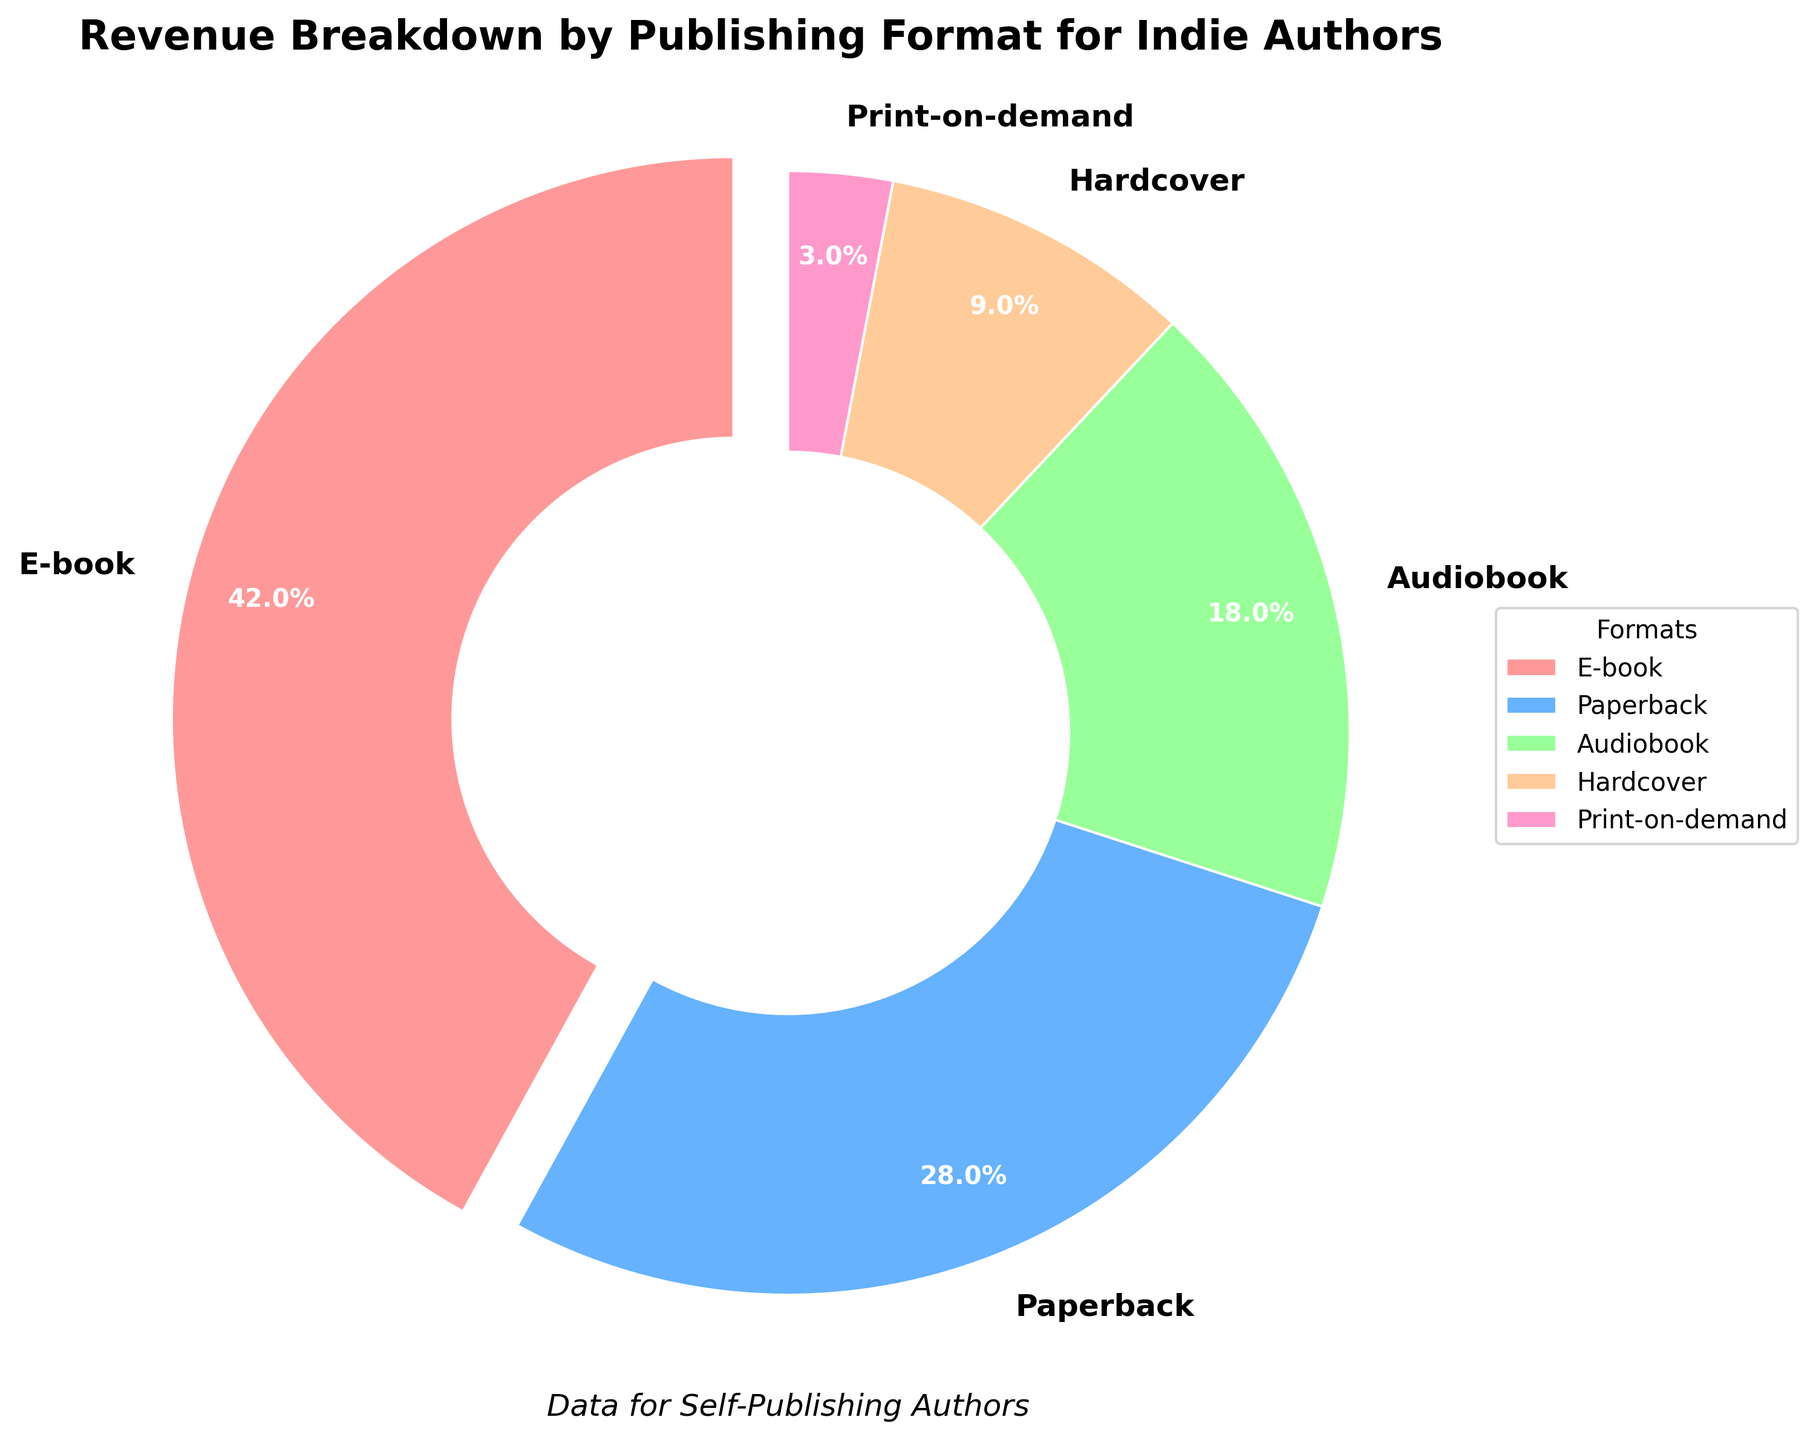What percentage of the revenue comes from e-books? The pie chart shows that the segment representing e-books is labeled with the percentage value.
Answer: 42% Which publishing format contributes the least to the revenue? By observing the size of the slices, the smallest slice will indicate the format contributing the least to the revenue.
Answer: Print-on-demand What is the combined percentage of revenue from paperback and hardcover formats? The percentages for paperback and hardcover are 28% and 9%, respectively. Summing them up, we get 28 + 9 = 37%.
Answer: 37% How does the revenue from audiobooks compare to that from print-on-demand? The percentages for audiobooks and print-on-demand are 18% and 3%, respectively. Audiobook revenue is greater than print-on-demand revenue.
Answer: Audiobooks > Print-on-demand Which color represents the hardcover format on the pie chart? The legend indicates the color associated with each format. The color for hardcover needs to be identified from this legend.
Answer: Peach (or '#FFCC99') What is the difference in revenue percentages between e-books and paperbacks? E-books contribute 42% while paperbacks contribute 28%. The difference is calculated as 42 - 28 = 14%.
Answer: 14% How much more revenue does the e-book format generate compared to the audiobook format? The revenue percentages for e-books and audiobooks are 42% and 18%, respectively. The difference is 42 - 18 = 24%.
Answer: 24% What formats are represented by the two largest segments on the pie chart? The largest percentages will correspond to the largest segments, hence identifying the top two formats.
Answer: E-book and Paperback What is the total percentage of revenue from non-e-book formats? Summing up the percentages of all formats except e-books: 28 (Paperback) + 18 (Audiobook) + 9 (Hardcover) + 3 (Print-on-demand) = 58%.
Answer: 58% Which format is represented by the segment with approximately 18%? The legend and segments label can be checked to identify the format with a value of around 18%.
Answer: Audiobook 